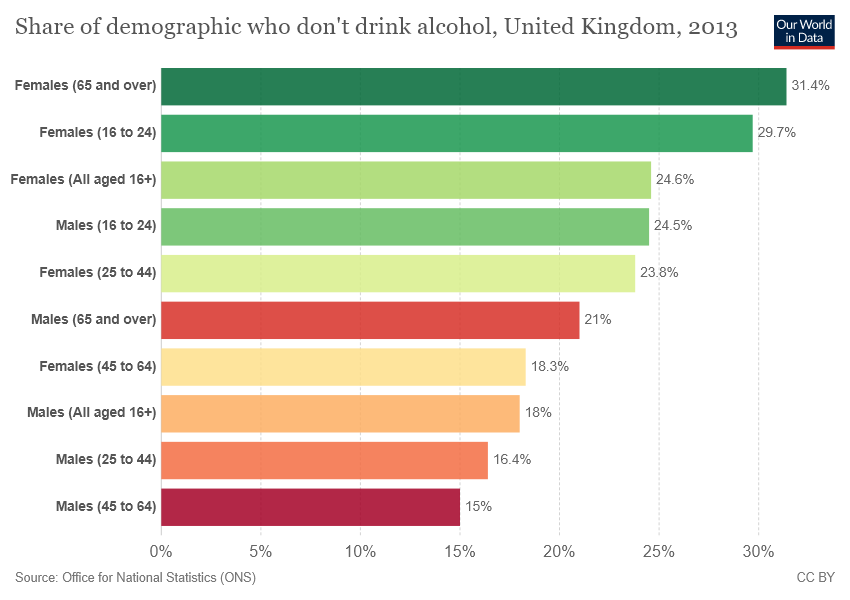List a handful of essential elements in this visual. The value of the first bar is 31.4. The sum of the smallest two bars is not greater than the value of the largest bar. 